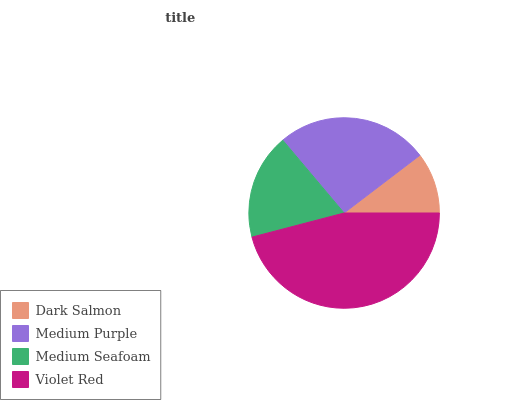Is Dark Salmon the minimum?
Answer yes or no. Yes. Is Violet Red the maximum?
Answer yes or no. Yes. Is Medium Purple the minimum?
Answer yes or no. No. Is Medium Purple the maximum?
Answer yes or no. No. Is Medium Purple greater than Dark Salmon?
Answer yes or no. Yes. Is Dark Salmon less than Medium Purple?
Answer yes or no. Yes. Is Dark Salmon greater than Medium Purple?
Answer yes or no. No. Is Medium Purple less than Dark Salmon?
Answer yes or no. No. Is Medium Purple the high median?
Answer yes or no. Yes. Is Medium Seafoam the low median?
Answer yes or no. Yes. Is Dark Salmon the high median?
Answer yes or no. No. Is Dark Salmon the low median?
Answer yes or no. No. 